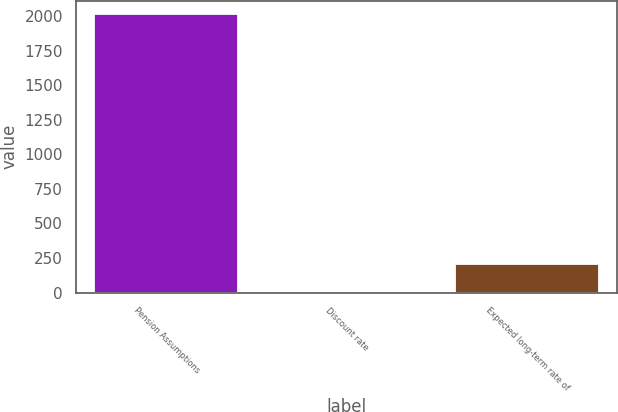Convert chart. <chart><loc_0><loc_0><loc_500><loc_500><bar_chart><fcel>Pension Assumptions<fcel>Discount rate<fcel>Expected long-term rate of<nl><fcel>2013<fcel>4.75<fcel>205.58<nl></chart> 